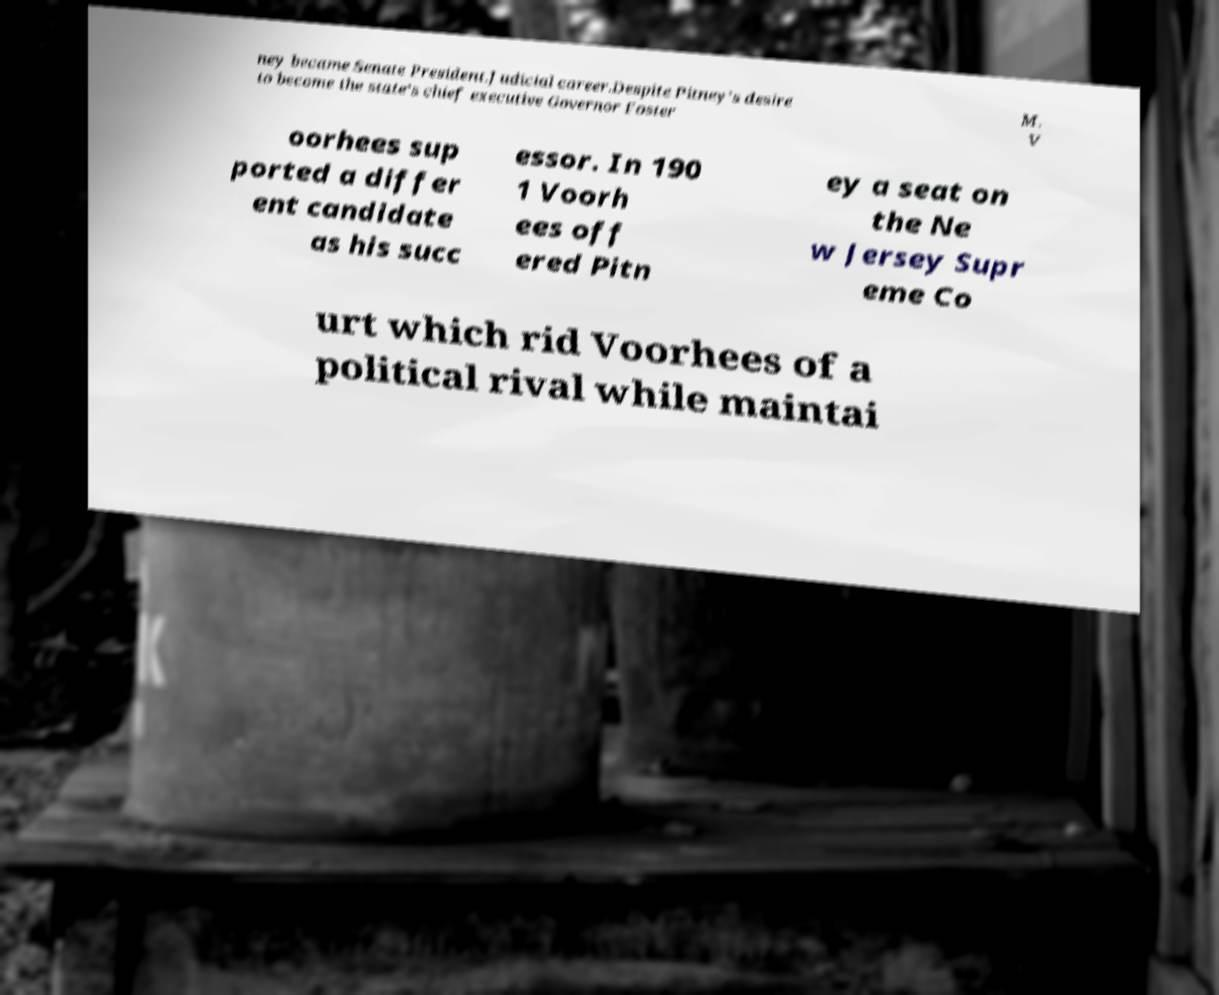I need the written content from this picture converted into text. Can you do that? ney became Senate President.Judicial career.Despite Pitney’s desire to become the state’s chief executive Governor Foster M. V oorhees sup ported a differ ent candidate as his succ essor. In 190 1 Voorh ees off ered Pitn ey a seat on the Ne w Jersey Supr eme Co urt which rid Voorhees of a political rival while maintai 